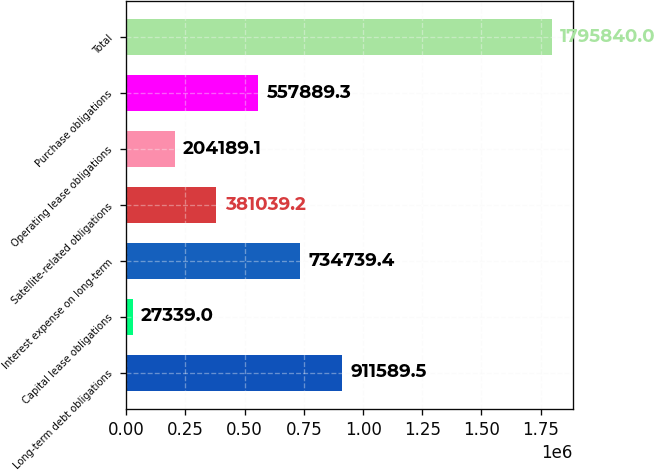<chart> <loc_0><loc_0><loc_500><loc_500><bar_chart><fcel>Long-term debt obligations<fcel>Capital lease obligations<fcel>Interest expense on long-term<fcel>Satellite-related obligations<fcel>Operating lease obligations<fcel>Purchase obligations<fcel>Total<nl><fcel>911590<fcel>27339<fcel>734739<fcel>381039<fcel>204189<fcel>557889<fcel>1.79584e+06<nl></chart> 